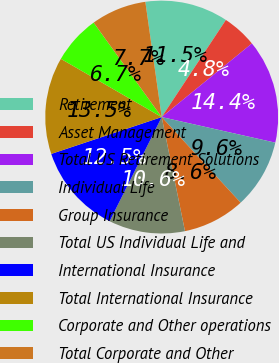Convert chart. <chart><loc_0><loc_0><loc_500><loc_500><pie_chart><fcel>Retirement<fcel>Asset Management<fcel>Total US Retirement Solutions<fcel>Individual Life<fcel>Group Insurance<fcel>Total US Individual Life and<fcel>International Insurance<fcel>Total International Insurance<fcel>Corporate and Other operations<fcel>Total Corporate and Other<nl><fcel>11.54%<fcel>4.81%<fcel>14.42%<fcel>9.62%<fcel>8.65%<fcel>10.58%<fcel>12.5%<fcel>13.46%<fcel>6.73%<fcel>7.69%<nl></chart> 